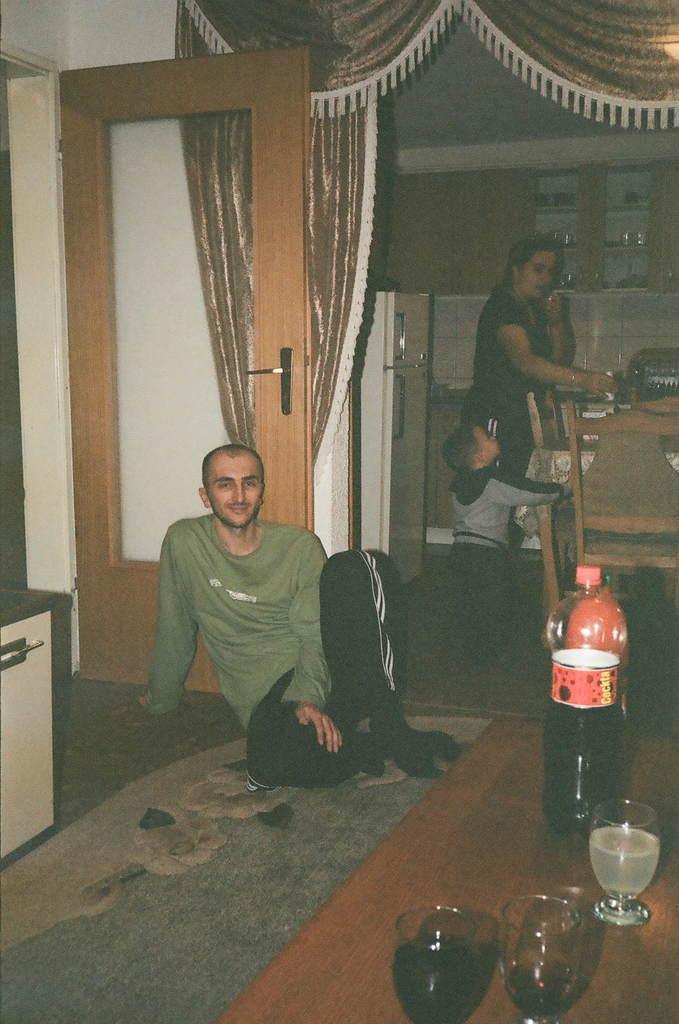Please provide a concise description of this image. in this image we can see a person sitting on the floor wearing green color t shirt and black color pant. On the right side of the image we can see a table on which a bottle is placed and there are three glasses in which there are drinks. In the background of the image we can see a child standing and a woman standing near the table and the chairs. on the top of the image we can see a curtains and in the left side of the image we can see a door. 